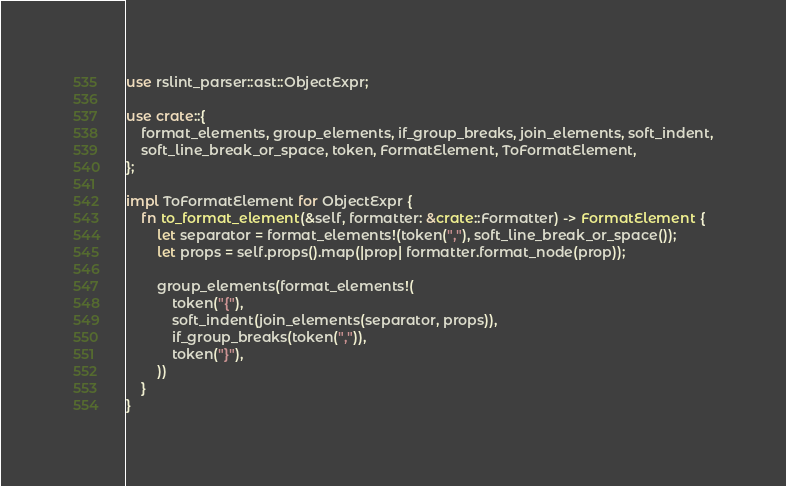<code> <loc_0><loc_0><loc_500><loc_500><_Rust_>use rslint_parser::ast::ObjectExpr;

use crate::{
	format_elements, group_elements, if_group_breaks, join_elements, soft_indent,
	soft_line_break_or_space, token, FormatElement, ToFormatElement,
};

impl ToFormatElement for ObjectExpr {
	fn to_format_element(&self, formatter: &crate::Formatter) -> FormatElement {
		let separator = format_elements!(token(","), soft_line_break_or_space());
		let props = self.props().map(|prop| formatter.format_node(prop));

		group_elements(format_elements!(
			token("{"),
			soft_indent(join_elements(separator, props)),
			if_group_breaks(token(",")),
			token("}"),
		))
	}
}
</code> 